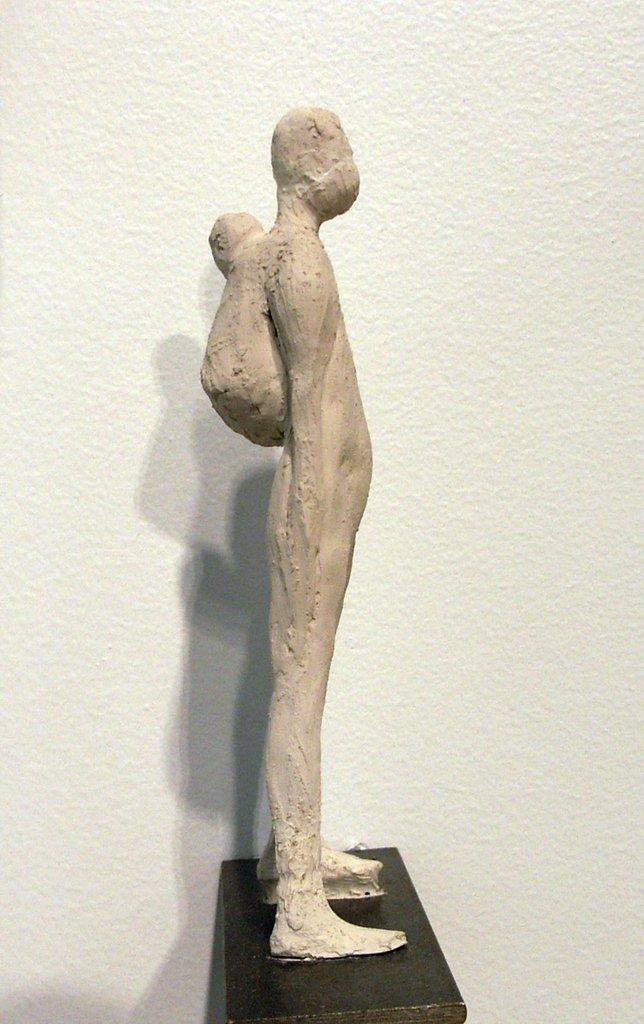What is the main subject of the image? There is a statue of a person in the image. What color is the statue? The statue is brown in color. What is the statue standing on? The statue is on a black colored object. What can be seen in the background of the image? There is a white colored wall in the background of the image. How does the statue express surprise in the image? The statue does not express surprise in the image, as it is a static object and not capable of expressing emotions. 